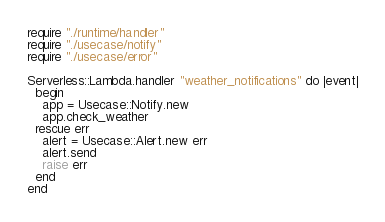Convert code to text. <code><loc_0><loc_0><loc_500><loc_500><_Crystal_>require "./runtime/handler"
require "./usecase/notify"
require "./usecase/error"

Serverless::Lambda.handler "weather_notifications" do |event|
  begin
    app = Usecase::Notify.new
    app.check_weather
  rescue err
    alert = Usecase::Alert.new err
    alert.send
    raise err
  end
end
</code> 